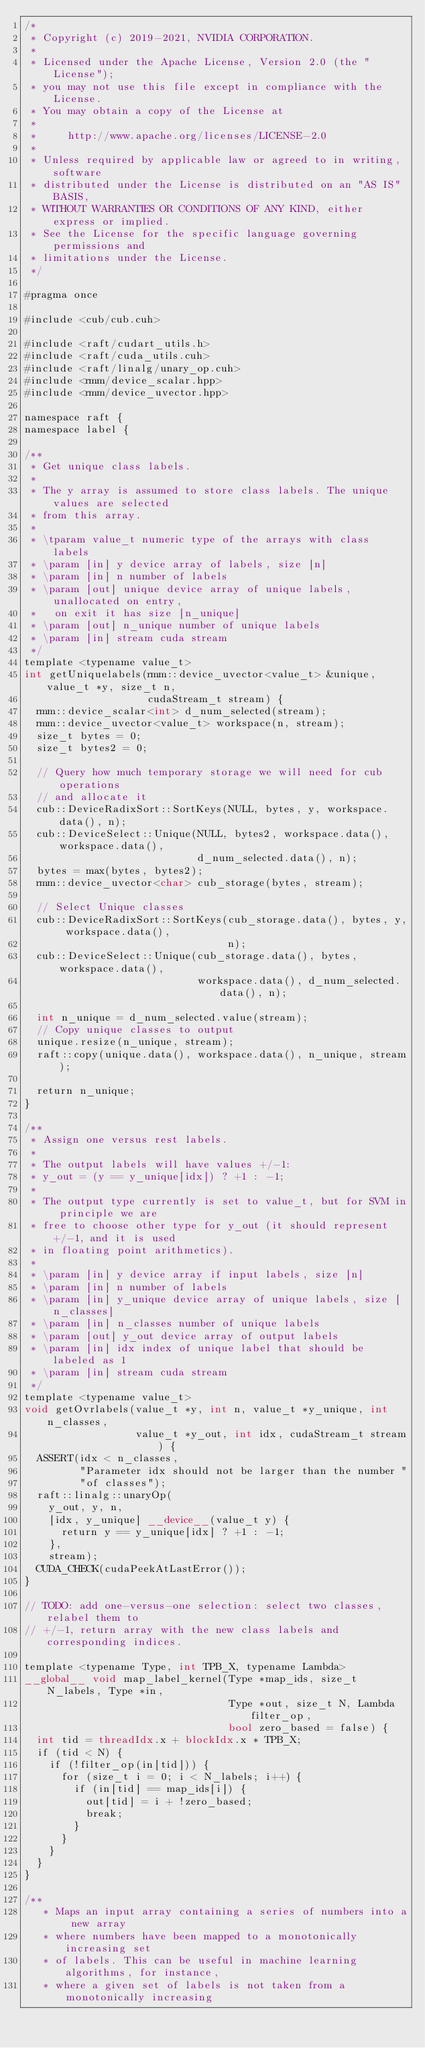Convert code to text. <code><loc_0><loc_0><loc_500><loc_500><_Cuda_>/*
 * Copyright (c) 2019-2021, NVIDIA CORPORATION.
 *
 * Licensed under the Apache License, Version 2.0 (the "License");
 * you may not use this file except in compliance with the License.
 * You may obtain a copy of the License at
 *
 *     http://www.apache.org/licenses/LICENSE-2.0
 *
 * Unless required by applicable law or agreed to in writing, software
 * distributed under the License is distributed on an "AS IS" BASIS,
 * WITHOUT WARRANTIES OR CONDITIONS OF ANY KIND, either express or implied.
 * See the License for the specific language governing permissions and
 * limitations under the License.
 */

#pragma once

#include <cub/cub.cuh>

#include <raft/cudart_utils.h>
#include <raft/cuda_utils.cuh>
#include <raft/linalg/unary_op.cuh>
#include <rmm/device_scalar.hpp>
#include <rmm/device_uvector.hpp>

namespace raft {
namespace label {

/**
 * Get unique class labels.
 *
 * The y array is assumed to store class labels. The unique values are selected
 * from this array.
 *
 * \tparam value_t numeric type of the arrays with class labels
 * \param [in] y device array of labels, size [n]
 * \param [in] n number of labels
 * \param [out] unique device array of unique labels, unallocated on entry,
 *   on exit it has size [n_unique]
 * \param [out] n_unique number of unique labels
 * \param [in] stream cuda stream
 */
template <typename value_t>
int getUniquelabels(rmm::device_uvector<value_t> &unique, value_t *y, size_t n,
                    cudaStream_t stream) {
  rmm::device_scalar<int> d_num_selected(stream);
  rmm::device_uvector<value_t> workspace(n, stream);
  size_t bytes = 0;
  size_t bytes2 = 0;

  // Query how much temporary storage we will need for cub operations
  // and allocate it
  cub::DeviceRadixSort::SortKeys(NULL, bytes, y, workspace.data(), n);
  cub::DeviceSelect::Unique(NULL, bytes2, workspace.data(), workspace.data(),
                            d_num_selected.data(), n);
  bytes = max(bytes, bytes2);
  rmm::device_uvector<char> cub_storage(bytes, stream);

  // Select Unique classes
  cub::DeviceRadixSort::SortKeys(cub_storage.data(), bytes, y, workspace.data(),
                                 n);
  cub::DeviceSelect::Unique(cub_storage.data(), bytes, workspace.data(),
                            workspace.data(), d_num_selected.data(), n);

  int n_unique = d_num_selected.value(stream);
  // Copy unique classes to output
  unique.resize(n_unique, stream);
  raft::copy(unique.data(), workspace.data(), n_unique, stream);

  return n_unique;
}

/**
 * Assign one versus rest labels.
 *
 * The output labels will have values +/-1:
 * y_out = (y == y_unique[idx]) ? +1 : -1;
 *
 * The output type currently is set to value_t, but for SVM in principle we are
 * free to choose other type for y_out (it should represent +/-1, and it is used
 * in floating point arithmetics).
 *
 * \param [in] y device array if input labels, size [n]
 * \param [in] n number of labels
 * \param [in] y_unique device array of unique labels, size [n_classes]
 * \param [in] n_classes number of unique labels
 * \param [out] y_out device array of output labels
 * \param [in] idx index of unique label that should be labeled as 1
 * \param [in] stream cuda stream
 */
template <typename value_t>
void getOvrlabels(value_t *y, int n, value_t *y_unique, int n_classes,
                  value_t *y_out, int idx, cudaStream_t stream) {
  ASSERT(idx < n_classes,
         "Parameter idx should not be larger than the number "
         "of classes");
  raft::linalg::unaryOp(
    y_out, y, n,
    [idx, y_unique] __device__(value_t y) {
      return y == y_unique[idx] ? +1 : -1;
    },
    stream);
  CUDA_CHECK(cudaPeekAtLastError());
}

// TODO: add one-versus-one selection: select two classes, relabel them to
// +/-1, return array with the new class labels and corresponding indices.

template <typename Type, int TPB_X, typename Lambda>
__global__ void map_label_kernel(Type *map_ids, size_t N_labels, Type *in,
                                 Type *out, size_t N, Lambda filter_op,
                                 bool zero_based = false) {
  int tid = threadIdx.x + blockIdx.x * TPB_X;
  if (tid < N) {
    if (!filter_op(in[tid])) {
      for (size_t i = 0; i < N_labels; i++) {
        if (in[tid] == map_ids[i]) {
          out[tid] = i + !zero_based;
          break;
        }
      }
    }
  }
}

/**
   * Maps an input array containing a series of numbers into a new array
   * where numbers have been mapped to a monotonically increasing set
   * of labels. This can be useful in machine learning algorithms, for instance,
   * where a given set of labels is not taken from a monotonically increasing</code> 